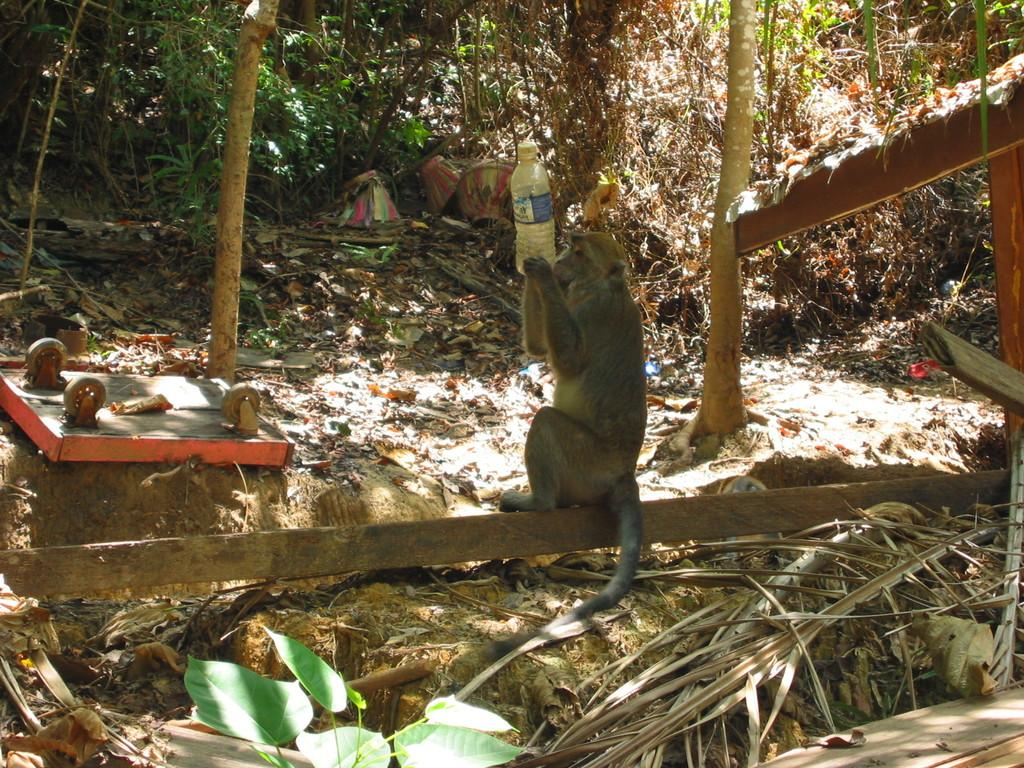What animal can be seen in the picture? There is a monkey in the picture. What is the monkey holding in the image? The monkey is holding a bottle. What type of vegetation is present in the image? There are plants and trees in the image. What can be found on the floor in the image? Dry leaves are present on the floor. How does the wren contribute to the increase in the number of leaves on the trees in the image? There is no wren present in the image, and therefore it cannot contribute to any increase in the number of leaves on the trees. 